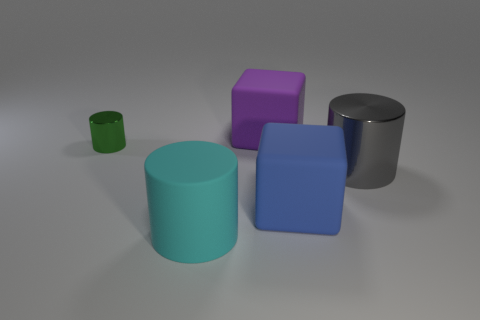Subtract all metallic cylinders. How many cylinders are left? 1 Add 1 red metal blocks. How many objects exist? 6 Subtract all yellow cylinders. Subtract all brown cubes. How many cylinders are left? 3 Subtract 0 purple balls. How many objects are left? 5 Subtract all cylinders. How many objects are left? 2 Subtract all large metallic cylinders. Subtract all big gray shiny cylinders. How many objects are left? 3 Add 4 large things. How many large things are left? 8 Add 3 purple matte cubes. How many purple matte cubes exist? 4 